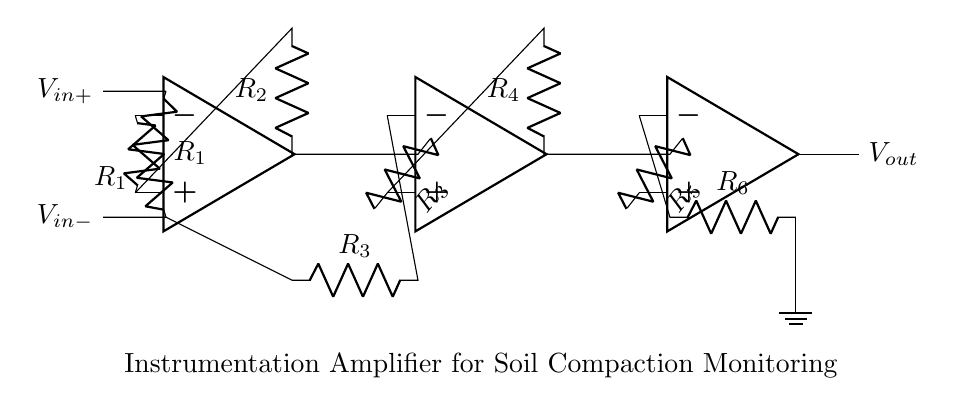What type of amplifier is shown in the circuit? The circuit diagram specifically illustrates an instrumentation amplifier, which is designed for high precision and low noise in signal amplification.
Answer: instrumentation amplifier What is the function of the resistors in the circuit? The resistors are used to set the gain and stabilize the feedback in the operational amplifier stages, ensuring accurate signal amplification.
Answer: gain setting and feedback stabilization How many operational amplifiers are used in this instrumentation amplifier? There are three operational amplifiers arranged in a specific configuration to achieve the desired input differential and output characteristics.
Answer: three What is the purpose of the input terminals labeled V_in+ and V_in-? The V_in+ and V_in- terminals serve as the differential input for the amplifier, allowing it to measure the difference in voltage between two inputs, which is crucial in precision applications like soil compaction monitoring.
Answer: differential input What is the output voltage denoted as in the circuit? The output voltage is labeled V_out, representing the amplified result of the input differential voltage processed through the instrumentation amplifier stages.
Answer: V_out What is the significance of the resistor labeling in the circuit? The resistors are labeled R_1, R_2, R_3, R_4, R_5, and R_6 to indicate their role in defining the gain and feedback loops of the amplifier, which are crucial for determining the amplifier’s performance characteristics.
Answer: defining gain and feedback What key feature differentiates an instrumentation amplifier from other amplifiers? An instrumentation amplifier is characterized by its ability to amplify small differential signals and reject large common-mode voltages, making it especially useful in noisy environments or sensitive measurements like soil compaction.
Answer: high common-mode rejection ratio 